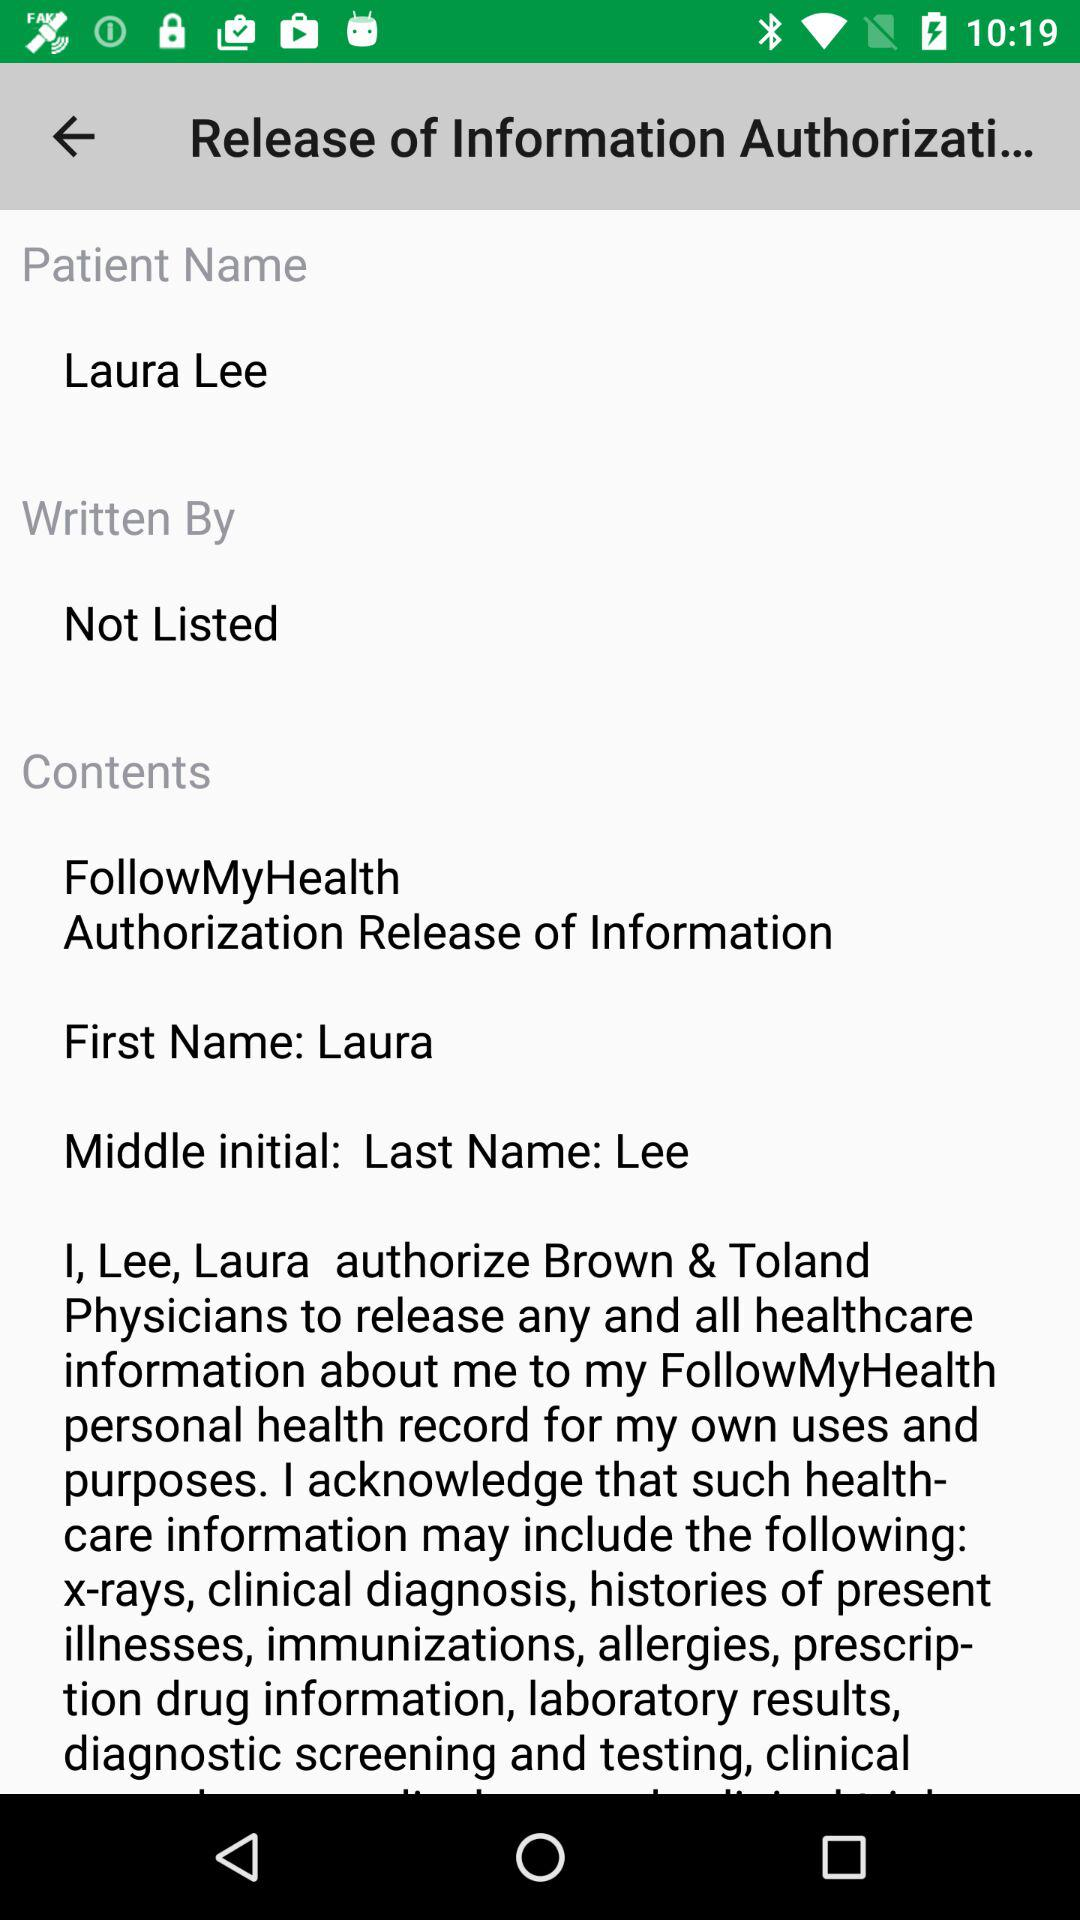To whom did Laura Lee give the authority? Laura Lee gave the authority to "Brown & Toland Physicians". 